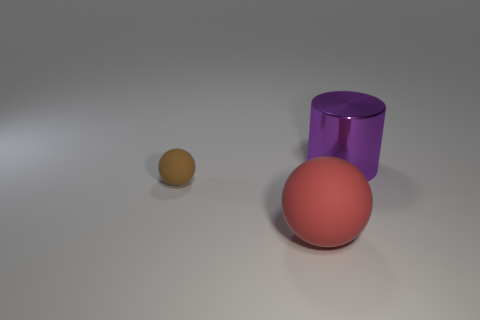Add 2 yellow blocks. How many objects exist? 5 Subtract all balls. How many objects are left? 1 Subtract all brown spheres. Subtract all blue cylinders. How many spheres are left? 1 Subtract all big gray matte cylinders. Subtract all rubber objects. How many objects are left? 1 Add 1 big purple metal things. How many big purple metal things are left? 2 Add 1 big matte objects. How many big matte objects exist? 2 Subtract 0 brown cylinders. How many objects are left? 3 